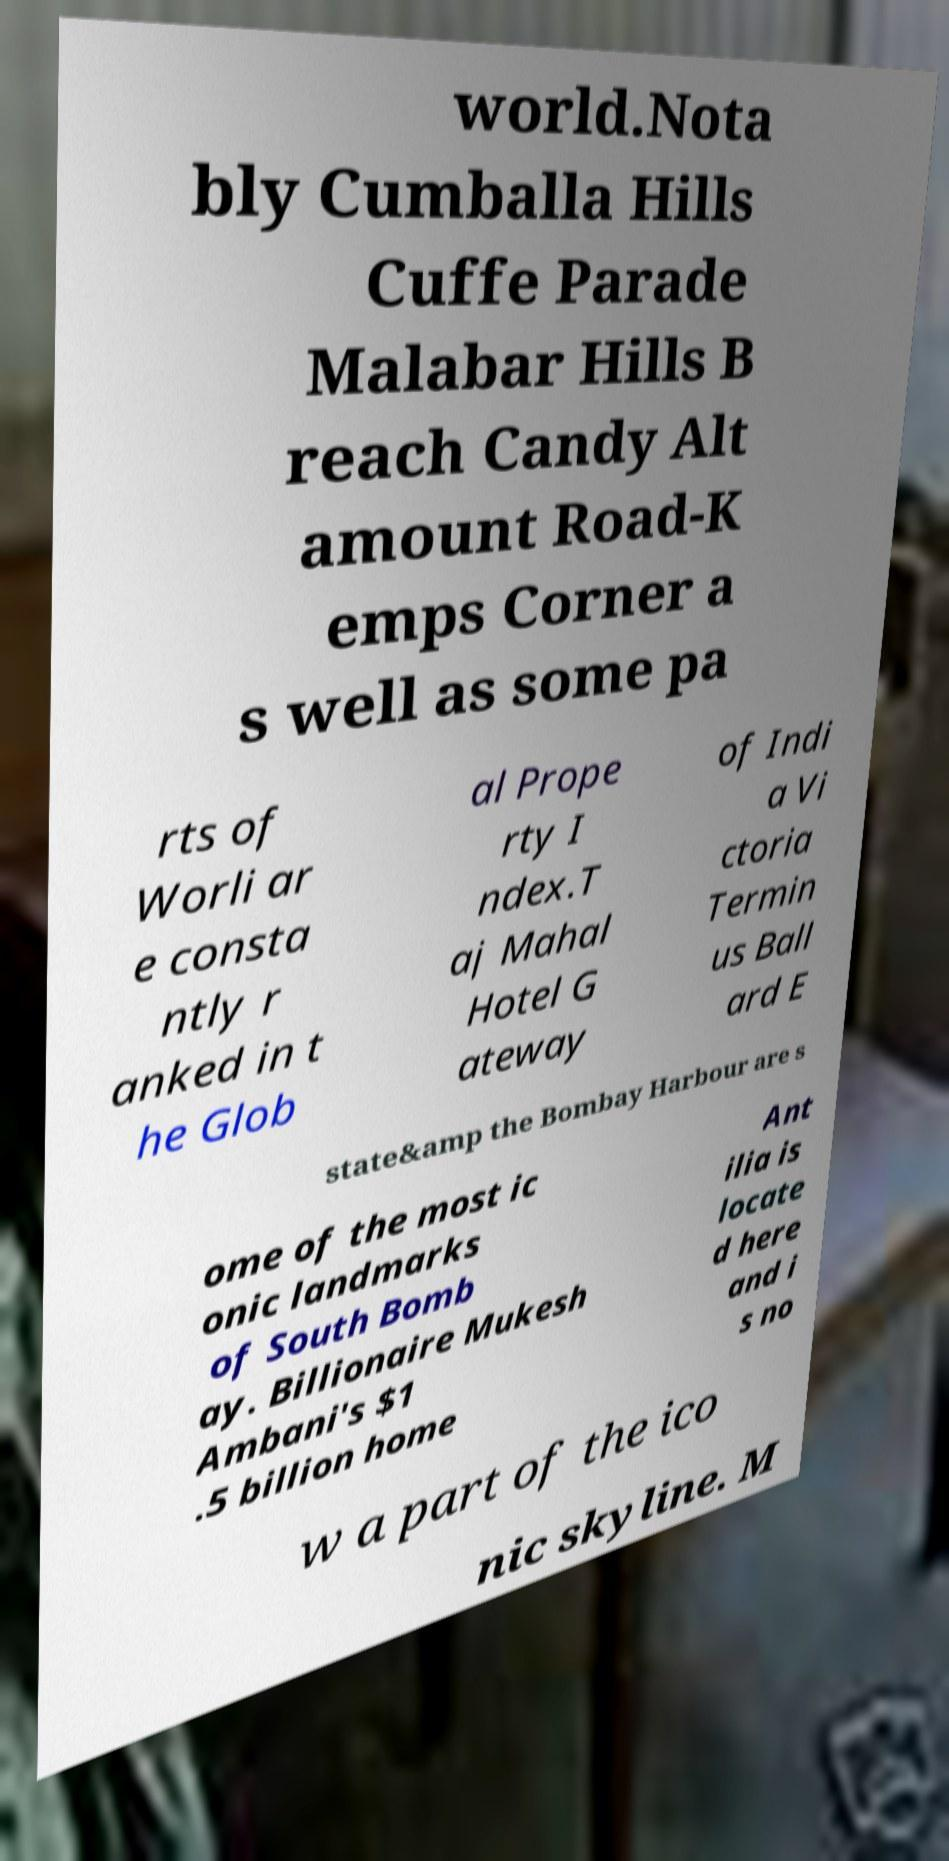What messages or text are displayed in this image? I need them in a readable, typed format. world.Nota bly Cumballa Hills Cuffe Parade Malabar Hills B reach Candy Alt amount Road-K emps Corner a s well as some pa rts of Worli ar e consta ntly r anked in t he Glob al Prope rty I ndex.T aj Mahal Hotel G ateway of Indi a Vi ctoria Termin us Ball ard E state&amp the Bombay Harbour are s ome of the most ic onic landmarks of South Bomb ay. Billionaire Mukesh Ambani's $1 .5 billion home Ant ilia is locate d here and i s no w a part of the ico nic skyline. M 